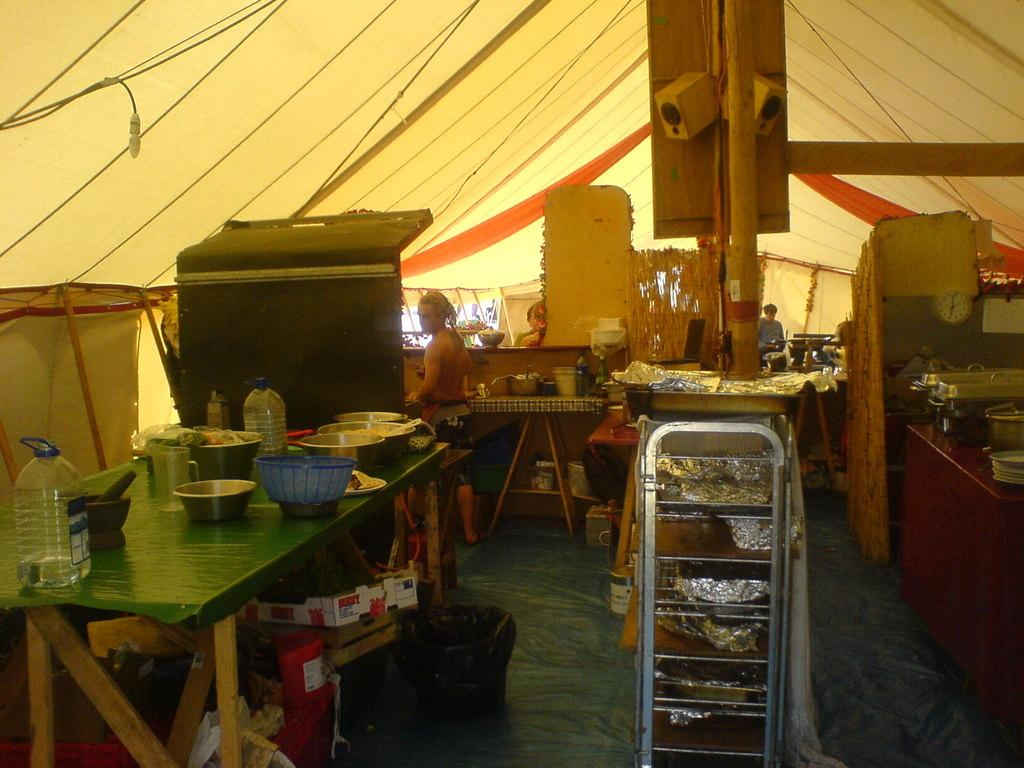Who is the person in the image? There is a man in the image. What is the man doing in the image? The man is cooking. Where is the man located in the image? The man is in a kitchen. What tools or equipment might the man be using to cook? There are utensils around the man. What type of furniture is the man sitting on while cooking in the image? There is no furniture visible in the image, as the man is standing while cooking. 